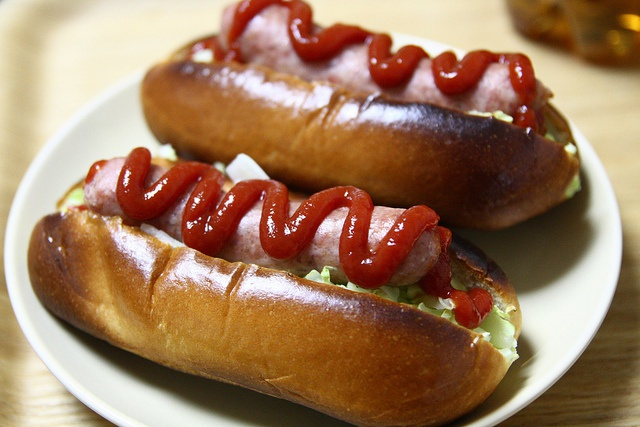Describe the objects in this image and their specific colors. I can see dining table in ivory, maroon, brown, black, and tan tones, hot dog in darkgray, maroon, and brown tones, and hot dog in darkgray, brown, maroon, black, and lightgray tones in this image. 